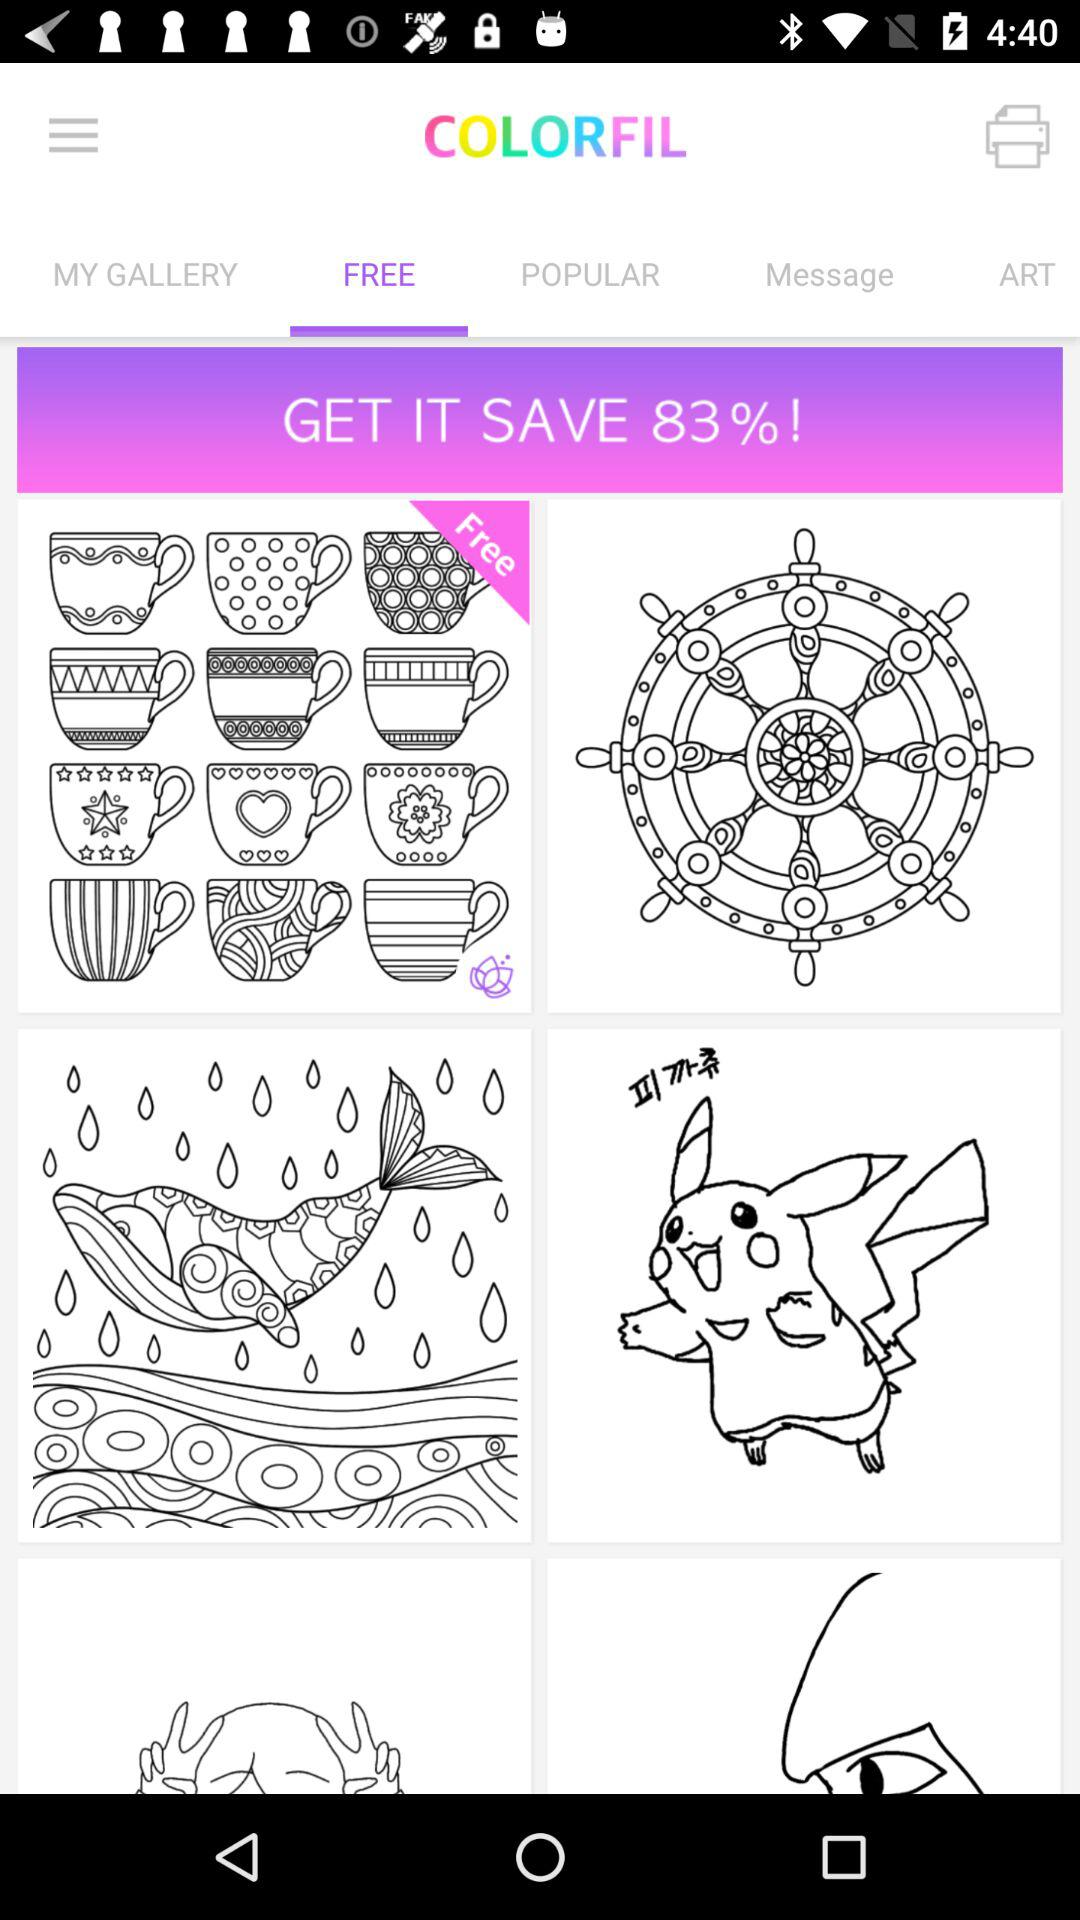What is the percentage I can save? You can save 83%. 